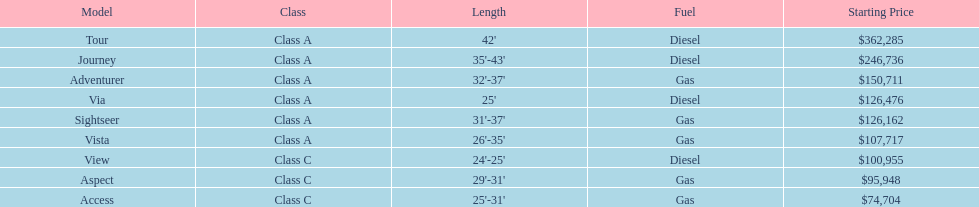What is the peak price for a winnebago model? $362,285. Write the full table. {'header': ['Model', 'Class', 'Length', 'Fuel', 'Starting Price'], 'rows': [['Tour', 'Class A', "42'", 'Diesel', '$362,285'], ['Journey', 'Class A', "35'-43'", 'Diesel', '$246,736'], ['Adventurer', 'Class A', "32'-37'", 'Gas', '$150,711'], ['Via', 'Class A', "25'", 'Diesel', '$126,476'], ['Sightseer', 'Class A', "31'-37'", 'Gas', '$126,162'], ['Vista', 'Class A', "26'-35'", 'Gas', '$107,717'], ['View', 'Class C', "24'-25'", 'Diesel', '$100,955'], ['Aspect', 'Class C', "29'-31'", 'Gas', '$95,948'], ['Access', 'Class C', "25'-31'", 'Gas', '$74,704']]} What is the name of the vehicle at this cost? Tour. 